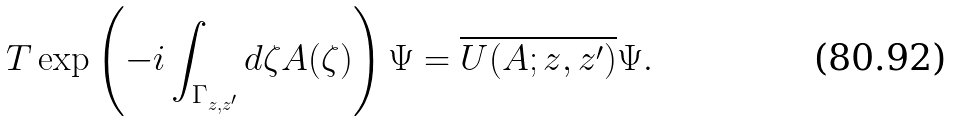<formula> <loc_0><loc_0><loc_500><loc_500>T \exp \left ( - i \int _ { \Gamma _ { z , z ^ { \prime } } } d \zeta A ( \zeta ) \right ) \Psi = \overline { U ( A ; z , z ^ { \prime } ) } \Psi .</formula> 